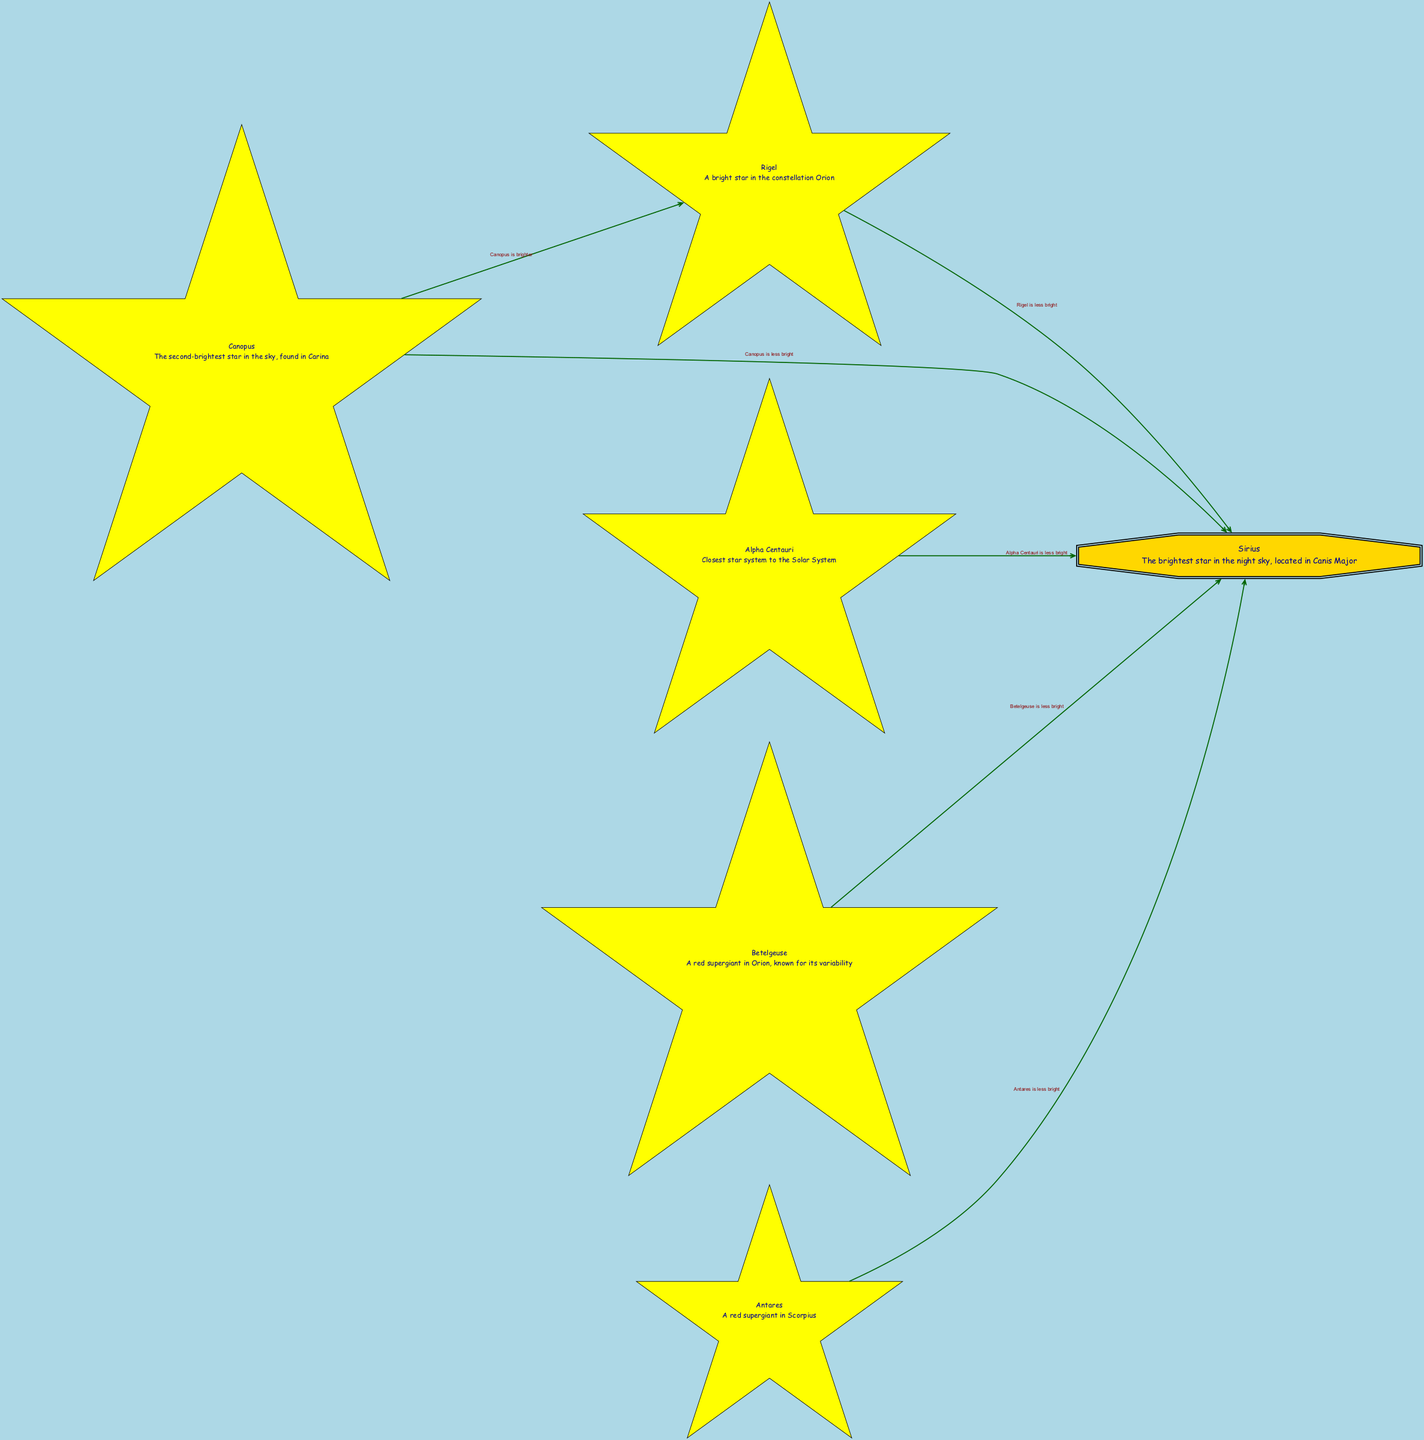What is the brightest star shown in the diagram? The diagram indicates that Sirius is the brightest star as it is placed at the topmost position and has a distinctive relationship to all other stars listed as being less bright.
Answer: Sirius How many stars are represented in the diagram? By counting the nodes labeled as stars, we find a total of six distinct stars depicted in the diagram.
Answer: 6 Which star is described as a red supergiant in Orion? Looking at the node descriptions, we can see that Betelgeuse is identified specifically as a red supergiant located in the Orion constellation.
Answer: Betelgeuse What relationship does Canopus have with Sirius? The diagram illustrates that Canopus is less bright than Sirius using a direct edge pointing from Canopus to Sirius with the corresponding relationship labeled.
Answer: Canopus is less bright Which star has the closest star system to the Solar System? The diagram mentions Alpha Centauri as the star closest to the Solar System, which is explicitly noted in its description node.
Answer: Alpha Centauri How many stars are described as less bright than Sirius? A review of the edges leading from Sirius shows that there are five stars (Rigel, Canopus, Alpha Centauri, Betelgeuse, and Antares) designated as less bright compared to Sirius.
Answer: 5 Is there any star that is brighter than Rigel according to the diagram? The diagram indicates that Canopus is brighter than Rigel, as evidenced by the edge pointing from Canopus to Rigel displaying that relationship.
Answer: Yes, Canopus Which star is known for its variability? The node description for Betelgeuse states that it is known for its variability, making this the answer to the question regarding variability.
Answer: Betelgeuse What color represents the star Sirius in the diagram? Sirius is highlighted with a double octagonal shape and filled with gold color, which is a distinct design choice in the diagram to emphasize its brightness.
Answer: Gold 